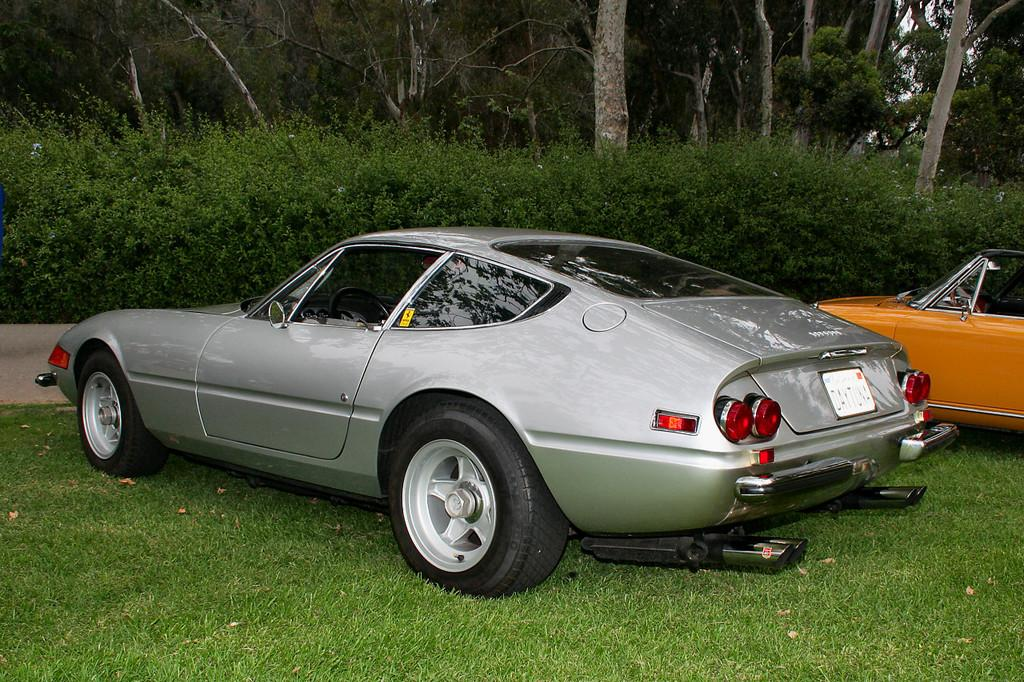How many vehicles can be seen in the image? There are two vehicles in the image. What type of natural elements are present in the image? There are trees, plants, and grass in the image. Where is the girl with the silver spot in the image? There is no girl or silver spot present in the image. 